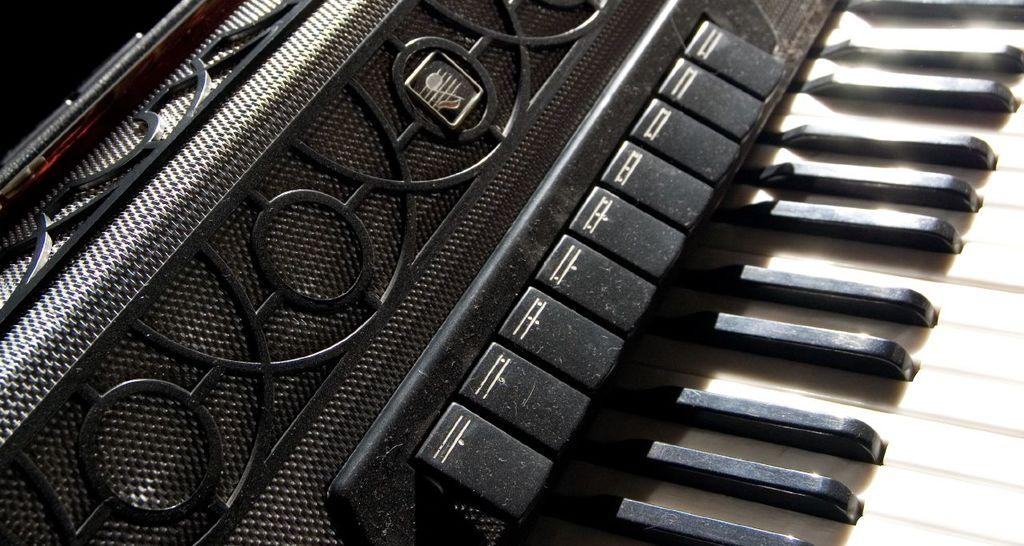What type of musical instrument is in the image? The musical instrument in the image resembles a keyboard. What are the two types of keys on the keyboard? The keyboard has white keys and black keys. How many dinosaurs are playing the keyboard in the image? There are no dinosaurs present in the image, and therefore no dinosaurs are playing the keyboard. What type of grip is required to play the keyboard in the image? The image does not show anyone playing the keyboard, so it is impossible to determine the type of grip required. 